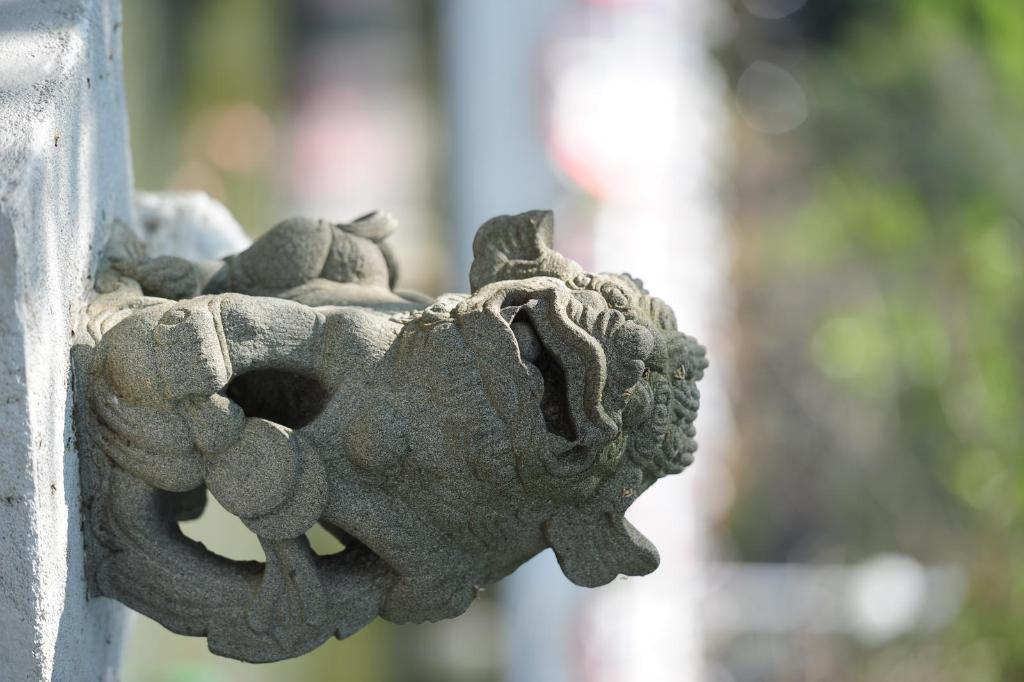What is the main subject in the center of the image? There is a sculpture in the center of the image. What can be seen in the background of the image? There are plants and lights visible in the background of the image. What type of market is visible in the image? There is no market present in the image; it features a sculpture and background elements. How does the snow affect the sculpture in the image? There is no snow present in the image, so it cannot affect the sculpture. 